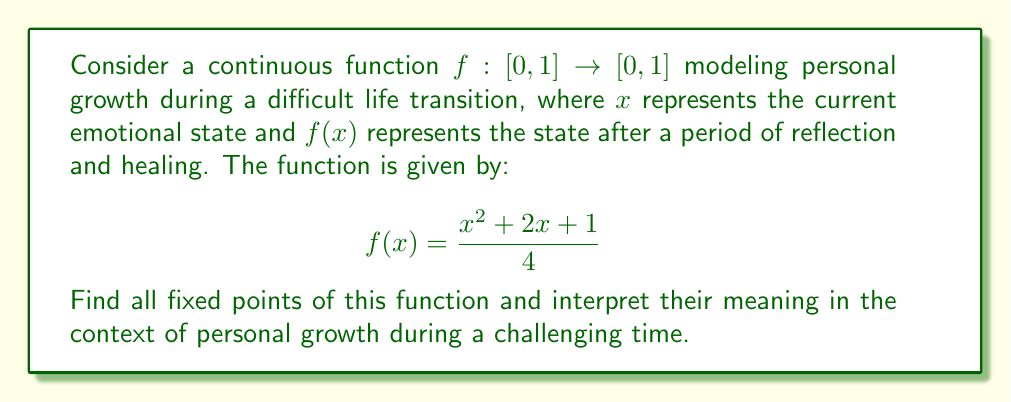Give your solution to this math problem. To find the fixed points of the function, we need to solve the equation $f(x) = x$. This gives us:

$$\frac{x^2 + 2x + 1}{4} = x$$

Multiplying both sides by 4:

$$x^2 + 2x + 1 = 4x$$

Rearranging the equation:

$$x^2 - 2x + 1 = 0$$

This is a quadratic equation. We can solve it using the quadratic formula:

$$x = \frac{-b \pm \sqrt{b^2 - 4ac}}{2a}$$

Where $a = 1$, $b = -2$, and $c = 1$

Substituting these values:

$$x = \frac{2 \pm \sqrt{4 - 4}}{2} = \frac{2 \pm 0}{2} = 1$$

Therefore, there is only one fixed point at $x = 1$.

Interpretation: In the context of personal growth during a challenging time like a separation, the fixed point at $x = 1$ represents a state of emotional stability and resilience. This suggests that regardless of the initial emotional state, continued reflection and healing (represented by repeated application of the function) will eventually lead to a stable emotional state. The fact that there is only one fixed point at the maximum value of the domain indicates that the model predicts eventual complete recovery and personal growth from the difficult experience.
Answer: The function has one fixed point at $x = 1$. 